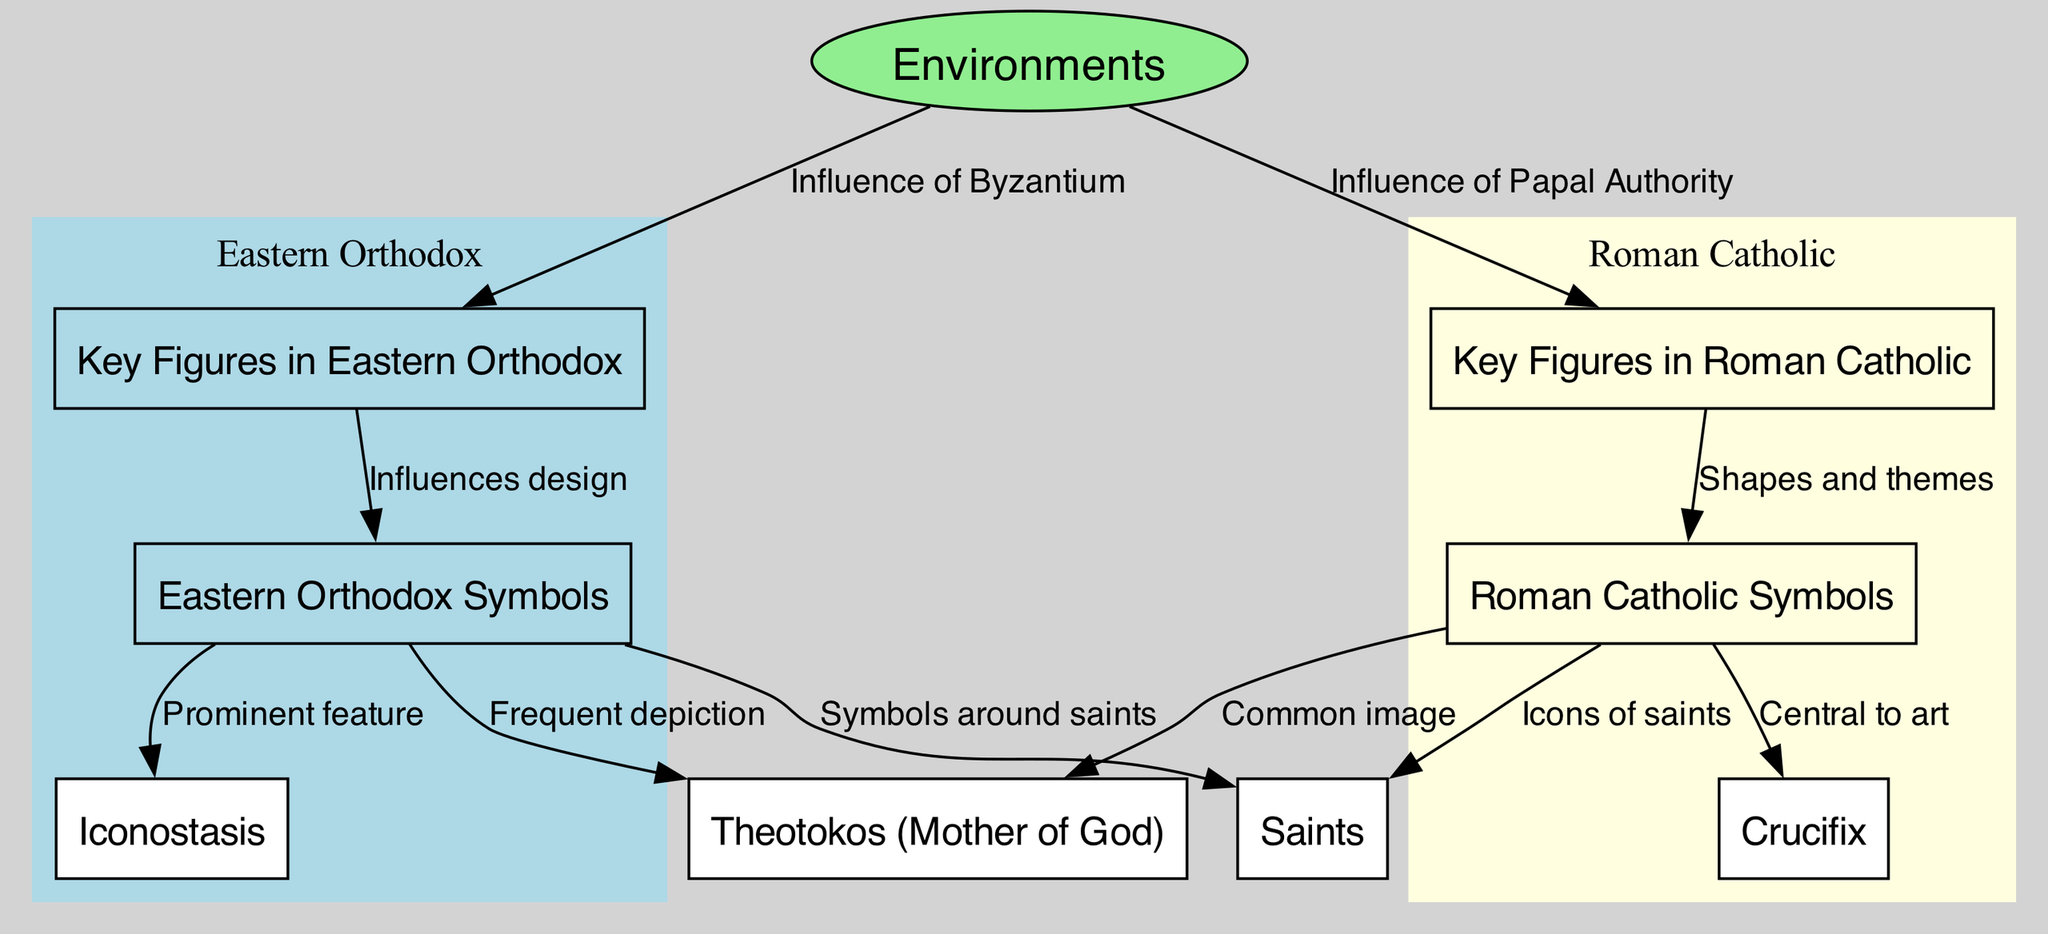What are the key figures in Eastern Orthodox art? The diagram lists "Key Figures in Eastern Orthodox" under the Eastern Orthodox section, indicating they are the notable religious icons from the Byzantine Empire.
Answer: Byzantine Empire's religious icons How many nodes represent Roman Catholic symbols? By examining the nodes in the Roman Catholic section, there are two specific nodes labeled "Roman Catholic Symbols" and "Crucifix." This gives us a total of two nodes.
Answer: 2 What is a prominent feature in Eastern Orthodox art? The edge labeled "Prominent feature" connects "Eastern Orthodox Symbols" and "Iconostasis." This relationship indicates that the Iconostasis is considered a prominent feature in Eastern Orthodox art.
Answer: Iconostasis Which symbol is central to Roman Catholic art? The relationship indicated by the edge labeled "Central to art" connects "Roman Catholic Symbols" and "Crucifix," demonstrating that the Crucifix is considered a central symbol within Roman Catholic art.
Answer: Crucifix How does Eastern Orthodox art frequently depict the Theotokos? The connection from "Eastern Orthodox Symbols" to "Theotokos (Mother of God)" is described as "Frequent depiction," showing that the Theotokos is a commonly represented figure in Eastern Orthodox art.
Answer: Frequent depiction What influences the design of Eastern Orthodox symbols? The diagram shows an edge labeled "Influences design" that connects "Key Figures in Eastern Orthodox" to "Eastern Orthodox Symbols," which indicates that the design of Eastern Orthodox symbols is heavily influenced by its key figures.
Answer: Key Figures in Eastern Orthodox Which type of saints' imagery is mentioned in the diagram? The nodes "Eastern Orthodox Symbols" and "Roman Catholic Symbols" both connect to "Saints," indicating that the imagery of saints is a common thematic element in both Eastern Orthodox and Roman Catholic art styles.
Answer: Depiction of revered holy figures What is the source of inspiration for Roman Catholic symbols? The edge labeled "Shapes and themes" connects "Key Figures in Roman Catholic" to "Roman Catholic Symbols," indicating that the shapes and themes of Roman Catholic art symbols are inspired by key figures from the Papacy and Western Church Fathers.
Answer: Papacy and Western Church Fathers How many connections does the node "Environments" have? The node "Environments" has two outgoing edges—one leading to "Key Figures in Eastern Orthodox" and one leading to "Key Figures in Roman Catholic." This shows that it has two connections in total.
Answer: 2 